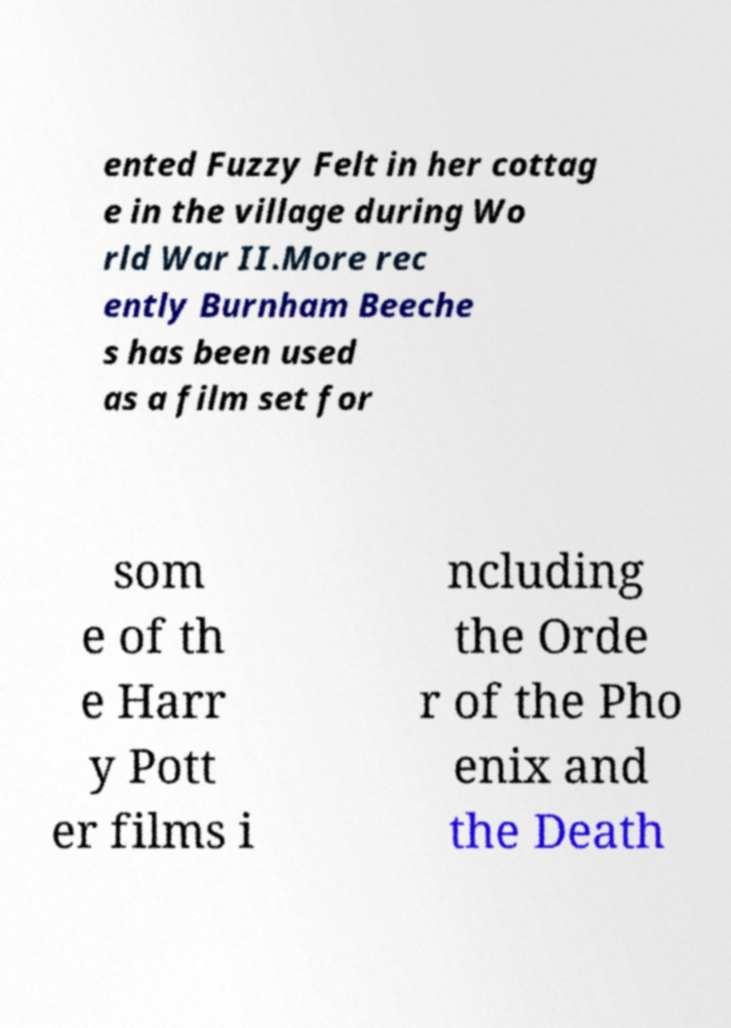Can you read and provide the text displayed in the image?This photo seems to have some interesting text. Can you extract and type it out for me? ented Fuzzy Felt in her cottag e in the village during Wo rld War II.More rec ently Burnham Beeche s has been used as a film set for som e of th e Harr y Pott er films i ncluding the Orde r of the Pho enix and the Death 